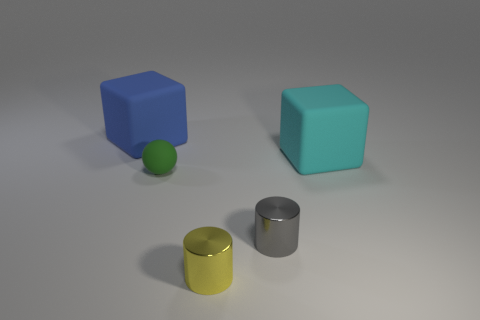Is the material of the big thing right of the big blue thing the same as the cube on the left side of the matte sphere?
Your answer should be compact. Yes. What number of small things have the same color as the tiny matte ball?
Your answer should be very brief. 0. There is a rubber object that is both left of the cyan rubber cube and in front of the blue rubber block; what shape is it?
Make the answer very short. Sphere. What color is the tiny object that is both on the left side of the gray metallic cylinder and behind the small yellow cylinder?
Make the answer very short. Green. Is the number of gray objects that are in front of the small yellow metal cylinder greater than the number of large blue rubber blocks in front of the small gray shiny object?
Offer a terse response. No. What is the color of the big rubber thing to the right of the large blue cube?
Provide a short and direct response. Cyan. Is the shape of the small thing that is on the right side of the small yellow cylinder the same as the large object right of the ball?
Your answer should be very brief. No. Is there a green sphere that has the same size as the yellow cylinder?
Offer a very short reply. Yes. There is a blue block that is on the left side of the small green matte object; what is its material?
Offer a very short reply. Rubber. Does the large block that is in front of the big blue rubber cube have the same material as the gray thing?
Make the answer very short. No. 